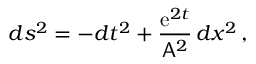Convert formula to latex. <formula><loc_0><loc_0><loc_500><loc_500>d s ^ { 2 } = - d t ^ { 2 } + \frac { e ^ { 2 t } } { A ^ { 2 } } \, d x ^ { 2 } \, ,</formula> 